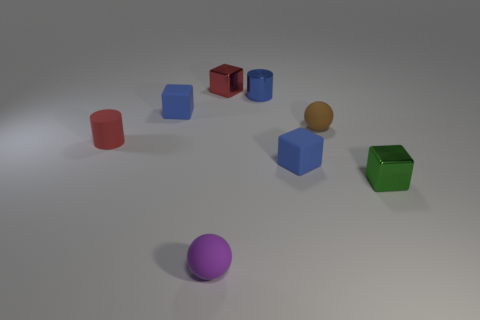Add 2 purple rubber objects. How many objects exist? 10 Subtract all red cubes. How many cubes are left? 3 Subtract all brown cylinders. How many blue blocks are left? 2 Subtract all small metallic objects. Subtract all tiny blue shiny things. How many objects are left? 4 Add 6 red cylinders. How many red cylinders are left? 7 Add 6 tiny red metal objects. How many tiny red metal objects exist? 7 Subtract 0 yellow blocks. How many objects are left? 8 Subtract 2 cylinders. How many cylinders are left? 0 Subtract all red balls. Subtract all purple cylinders. How many balls are left? 2 